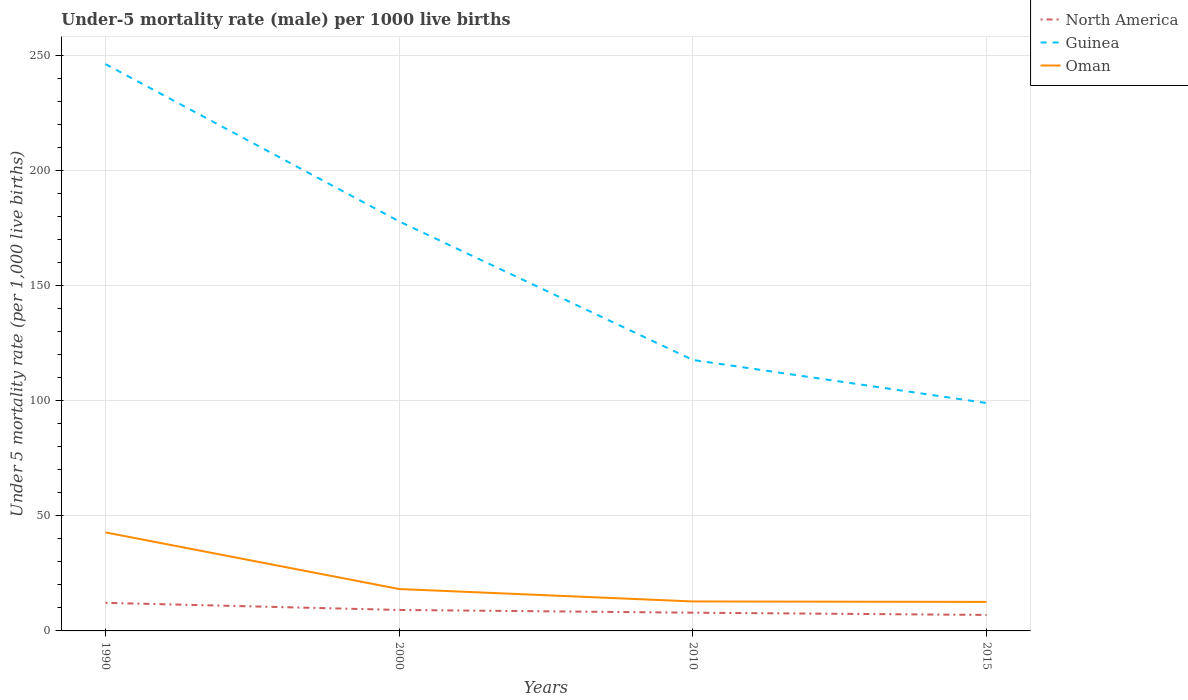Across all years, what is the maximum under-five mortality rate in Oman?
Provide a short and direct response. 12.6. In which year was the under-five mortality rate in Oman maximum?
Give a very brief answer. 2015. What is the total under-five mortality rate in Oman in the graph?
Ensure brevity in your answer.  0.2. What is the difference between the highest and the second highest under-five mortality rate in Guinea?
Your answer should be very brief. 147.2. Is the under-five mortality rate in Guinea strictly greater than the under-five mortality rate in North America over the years?
Provide a succinct answer. No. How many lines are there?
Make the answer very short. 3. How many years are there in the graph?
Your response must be concise. 4. What is the difference between two consecutive major ticks on the Y-axis?
Give a very brief answer. 50. Are the values on the major ticks of Y-axis written in scientific E-notation?
Provide a succinct answer. No. Does the graph contain any zero values?
Your response must be concise. No. How are the legend labels stacked?
Offer a terse response. Vertical. What is the title of the graph?
Keep it short and to the point. Under-5 mortality rate (male) per 1000 live births. Does "Liberia" appear as one of the legend labels in the graph?
Your answer should be compact. No. What is the label or title of the Y-axis?
Ensure brevity in your answer.  Under 5 mortality rate (per 1,0 live births). What is the Under 5 mortality rate (per 1,000 live births) of North America in 1990?
Provide a short and direct response. 12.2. What is the Under 5 mortality rate (per 1,000 live births) of Guinea in 1990?
Offer a very short reply. 246.2. What is the Under 5 mortality rate (per 1,000 live births) in Oman in 1990?
Your answer should be very brief. 42.8. What is the Under 5 mortality rate (per 1,000 live births) of North America in 2000?
Make the answer very short. 9.11. What is the Under 5 mortality rate (per 1,000 live births) in Guinea in 2000?
Offer a very short reply. 177.9. What is the Under 5 mortality rate (per 1,000 live births) of Oman in 2000?
Provide a short and direct response. 18.2. What is the Under 5 mortality rate (per 1,000 live births) of North America in 2010?
Provide a short and direct response. 7.92. What is the Under 5 mortality rate (per 1,000 live births) in Guinea in 2010?
Provide a short and direct response. 117.7. What is the Under 5 mortality rate (per 1,000 live births) of Oman in 2010?
Your answer should be compact. 12.8. What is the Under 5 mortality rate (per 1,000 live births) of North America in 2015?
Your answer should be compact. 6.94. What is the Under 5 mortality rate (per 1,000 live births) of Oman in 2015?
Your answer should be compact. 12.6. Across all years, what is the maximum Under 5 mortality rate (per 1,000 live births) of North America?
Provide a succinct answer. 12.2. Across all years, what is the maximum Under 5 mortality rate (per 1,000 live births) of Guinea?
Your response must be concise. 246.2. Across all years, what is the maximum Under 5 mortality rate (per 1,000 live births) in Oman?
Provide a short and direct response. 42.8. Across all years, what is the minimum Under 5 mortality rate (per 1,000 live births) in North America?
Your answer should be very brief. 6.94. Across all years, what is the minimum Under 5 mortality rate (per 1,000 live births) in Guinea?
Keep it short and to the point. 99. What is the total Under 5 mortality rate (per 1,000 live births) in North America in the graph?
Offer a terse response. 36.17. What is the total Under 5 mortality rate (per 1,000 live births) in Guinea in the graph?
Offer a very short reply. 640.8. What is the total Under 5 mortality rate (per 1,000 live births) in Oman in the graph?
Your answer should be compact. 86.4. What is the difference between the Under 5 mortality rate (per 1,000 live births) in North America in 1990 and that in 2000?
Ensure brevity in your answer.  3.09. What is the difference between the Under 5 mortality rate (per 1,000 live births) of Guinea in 1990 and that in 2000?
Offer a terse response. 68.3. What is the difference between the Under 5 mortality rate (per 1,000 live births) of Oman in 1990 and that in 2000?
Your answer should be compact. 24.6. What is the difference between the Under 5 mortality rate (per 1,000 live births) of North America in 1990 and that in 2010?
Offer a terse response. 4.28. What is the difference between the Under 5 mortality rate (per 1,000 live births) of Guinea in 1990 and that in 2010?
Your answer should be very brief. 128.5. What is the difference between the Under 5 mortality rate (per 1,000 live births) in Oman in 1990 and that in 2010?
Provide a short and direct response. 30. What is the difference between the Under 5 mortality rate (per 1,000 live births) in North America in 1990 and that in 2015?
Your response must be concise. 5.26. What is the difference between the Under 5 mortality rate (per 1,000 live births) of Guinea in 1990 and that in 2015?
Make the answer very short. 147.2. What is the difference between the Under 5 mortality rate (per 1,000 live births) of Oman in 1990 and that in 2015?
Keep it short and to the point. 30.2. What is the difference between the Under 5 mortality rate (per 1,000 live births) in North America in 2000 and that in 2010?
Ensure brevity in your answer.  1.19. What is the difference between the Under 5 mortality rate (per 1,000 live births) of Guinea in 2000 and that in 2010?
Your answer should be compact. 60.2. What is the difference between the Under 5 mortality rate (per 1,000 live births) in Oman in 2000 and that in 2010?
Ensure brevity in your answer.  5.4. What is the difference between the Under 5 mortality rate (per 1,000 live births) of North America in 2000 and that in 2015?
Your answer should be very brief. 2.17. What is the difference between the Under 5 mortality rate (per 1,000 live births) of Guinea in 2000 and that in 2015?
Your answer should be very brief. 78.9. What is the difference between the Under 5 mortality rate (per 1,000 live births) of Guinea in 2010 and that in 2015?
Your answer should be compact. 18.7. What is the difference between the Under 5 mortality rate (per 1,000 live births) of North America in 1990 and the Under 5 mortality rate (per 1,000 live births) of Guinea in 2000?
Your answer should be compact. -165.7. What is the difference between the Under 5 mortality rate (per 1,000 live births) of North America in 1990 and the Under 5 mortality rate (per 1,000 live births) of Oman in 2000?
Give a very brief answer. -6. What is the difference between the Under 5 mortality rate (per 1,000 live births) in Guinea in 1990 and the Under 5 mortality rate (per 1,000 live births) in Oman in 2000?
Make the answer very short. 228. What is the difference between the Under 5 mortality rate (per 1,000 live births) of North America in 1990 and the Under 5 mortality rate (per 1,000 live births) of Guinea in 2010?
Your answer should be compact. -105.5. What is the difference between the Under 5 mortality rate (per 1,000 live births) of North America in 1990 and the Under 5 mortality rate (per 1,000 live births) of Oman in 2010?
Your answer should be very brief. -0.6. What is the difference between the Under 5 mortality rate (per 1,000 live births) of Guinea in 1990 and the Under 5 mortality rate (per 1,000 live births) of Oman in 2010?
Offer a very short reply. 233.4. What is the difference between the Under 5 mortality rate (per 1,000 live births) in North America in 1990 and the Under 5 mortality rate (per 1,000 live births) in Guinea in 2015?
Give a very brief answer. -86.8. What is the difference between the Under 5 mortality rate (per 1,000 live births) in North America in 1990 and the Under 5 mortality rate (per 1,000 live births) in Oman in 2015?
Offer a terse response. -0.4. What is the difference between the Under 5 mortality rate (per 1,000 live births) in Guinea in 1990 and the Under 5 mortality rate (per 1,000 live births) in Oman in 2015?
Give a very brief answer. 233.6. What is the difference between the Under 5 mortality rate (per 1,000 live births) in North America in 2000 and the Under 5 mortality rate (per 1,000 live births) in Guinea in 2010?
Ensure brevity in your answer.  -108.59. What is the difference between the Under 5 mortality rate (per 1,000 live births) of North America in 2000 and the Under 5 mortality rate (per 1,000 live births) of Oman in 2010?
Your answer should be compact. -3.69. What is the difference between the Under 5 mortality rate (per 1,000 live births) of Guinea in 2000 and the Under 5 mortality rate (per 1,000 live births) of Oman in 2010?
Provide a succinct answer. 165.1. What is the difference between the Under 5 mortality rate (per 1,000 live births) in North America in 2000 and the Under 5 mortality rate (per 1,000 live births) in Guinea in 2015?
Offer a terse response. -89.89. What is the difference between the Under 5 mortality rate (per 1,000 live births) of North America in 2000 and the Under 5 mortality rate (per 1,000 live births) of Oman in 2015?
Your answer should be very brief. -3.49. What is the difference between the Under 5 mortality rate (per 1,000 live births) in Guinea in 2000 and the Under 5 mortality rate (per 1,000 live births) in Oman in 2015?
Provide a short and direct response. 165.3. What is the difference between the Under 5 mortality rate (per 1,000 live births) of North America in 2010 and the Under 5 mortality rate (per 1,000 live births) of Guinea in 2015?
Provide a short and direct response. -91.08. What is the difference between the Under 5 mortality rate (per 1,000 live births) of North America in 2010 and the Under 5 mortality rate (per 1,000 live births) of Oman in 2015?
Make the answer very short. -4.68. What is the difference between the Under 5 mortality rate (per 1,000 live births) in Guinea in 2010 and the Under 5 mortality rate (per 1,000 live births) in Oman in 2015?
Your answer should be very brief. 105.1. What is the average Under 5 mortality rate (per 1,000 live births) of North America per year?
Give a very brief answer. 9.04. What is the average Under 5 mortality rate (per 1,000 live births) in Guinea per year?
Ensure brevity in your answer.  160.2. What is the average Under 5 mortality rate (per 1,000 live births) in Oman per year?
Your answer should be compact. 21.6. In the year 1990, what is the difference between the Under 5 mortality rate (per 1,000 live births) in North America and Under 5 mortality rate (per 1,000 live births) in Guinea?
Make the answer very short. -234. In the year 1990, what is the difference between the Under 5 mortality rate (per 1,000 live births) of North America and Under 5 mortality rate (per 1,000 live births) of Oman?
Your answer should be compact. -30.6. In the year 1990, what is the difference between the Under 5 mortality rate (per 1,000 live births) in Guinea and Under 5 mortality rate (per 1,000 live births) in Oman?
Keep it short and to the point. 203.4. In the year 2000, what is the difference between the Under 5 mortality rate (per 1,000 live births) in North America and Under 5 mortality rate (per 1,000 live births) in Guinea?
Keep it short and to the point. -168.79. In the year 2000, what is the difference between the Under 5 mortality rate (per 1,000 live births) of North America and Under 5 mortality rate (per 1,000 live births) of Oman?
Your answer should be compact. -9.09. In the year 2000, what is the difference between the Under 5 mortality rate (per 1,000 live births) of Guinea and Under 5 mortality rate (per 1,000 live births) of Oman?
Offer a very short reply. 159.7. In the year 2010, what is the difference between the Under 5 mortality rate (per 1,000 live births) in North America and Under 5 mortality rate (per 1,000 live births) in Guinea?
Your answer should be compact. -109.78. In the year 2010, what is the difference between the Under 5 mortality rate (per 1,000 live births) in North America and Under 5 mortality rate (per 1,000 live births) in Oman?
Ensure brevity in your answer.  -4.88. In the year 2010, what is the difference between the Under 5 mortality rate (per 1,000 live births) of Guinea and Under 5 mortality rate (per 1,000 live births) of Oman?
Offer a terse response. 104.9. In the year 2015, what is the difference between the Under 5 mortality rate (per 1,000 live births) in North America and Under 5 mortality rate (per 1,000 live births) in Guinea?
Provide a short and direct response. -92.06. In the year 2015, what is the difference between the Under 5 mortality rate (per 1,000 live births) in North America and Under 5 mortality rate (per 1,000 live births) in Oman?
Your answer should be compact. -5.66. In the year 2015, what is the difference between the Under 5 mortality rate (per 1,000 live births) in Guinea and Under 5 mortality rate (per 1,000 live births) in Oman?
Your answer should be very brief. 86.4. What is the ratio of the Under 5 mortality rate (per 1,000 live births) of North America in 1990 to that in 2000?
Ensure brevity in your answer.  1.34. What is the ratio of the Under 5 mortality rate (per 1,000 live births) of Guinea in 1990 to that in 2000?
Make the answer very short. 1.38. What is the ratio of the Under 5 mortality rate (per 1,000 live births) of Oman in 1990 to that in 2000?
Your answer should be compact. 2.35. What is the ratio of the Under 5 mortality rate (per 1,000 live births) of North America in 1990 to that in 2010?
Offer a terse response. 1.54. What is the ratio of the Under 5 mortality rate (per 1,000 live births) of Guinea in 1990 to that in 2010?
Provide a succinct answer. 2.09. What is the ratio of the Under 5 mortality rate (per 1,000 live births) of Oman in 1990 to that in 2010?
Provide a succinct answer. 3.34. What is the ratio of the Under 5 mortality rate (per 1,000 live births) in North America in 1990 to that in 2015?
Make the answer very short. 1.76. What is the ratio of the Under 5 mortality rate (per 1,000 live births) in Guinea in 1990 to that in 2015?
Make the answer very short. 2.49. What is the ratio of the Under 5 mortality rate (per 1,000 live births) in Oman in 1990 to that in 2015?
Provide a short and direct response. 3.4. What is the ratio of the Under 5 mortality rate (per 1,000 live births) of North America in 2000 to that in 2010?
Provide a short and direct response. 1.15. What is the ratio of the Under 5 mortality rate (per 1,000 live births) of Guinea in 2000 to that in 2010?
Provide a succinct answer. 1.51. What is the ratio of the Under 5 mortality rate (per 1,000 live births) in Oman in 2000 to that in 2010?
Make the answer very short. 1.42. What is the ratio of the Under 5 mortality rate (per 1,000 live births) in North America in 2000 to that in 2015?
Provide a short and direct response. 1.31. What is the ratio of the Under 5 mortality rate (per 1,000 live births) in Guinea in 2000 to that in 2015?
Keep it short and to the point. 1.8. What is the ratio of the Under 5 mortality rate (per 1,000 live births) in Oman in 2000 to that in 2015?
Give a very brief answer. 1.44. What is the ratio of the Under 5 mortality rate (per 1,000 live births) of North America in 2010 to that in 2015?
Your answer should be very brief. 1.14. What is the ratio of the Under 5 mortality rate (per 1,000 live births) in Guinea in 2010 to that in 2015?
Keep it short and to the point. 1.19. What is the ratio of the Under 5 mortality rate (per 1,000 live births) in Oman in 2010 to that in 2015?
Give a very brief answer. 1.02. What is the difference between the highest and the second highest Under 5 mortality rate (per 1,000 live births) in North America?
Offer a terse response. 3.09. What is the difference between the highest and the second highest Under 5 mortality rate (per 1,000 live births) of Guinea?
Ensure brevity in your answer.  68.3. What is the difference between the highest and the second highest Under 5 mortality rate (per 1,000 live births) in Oman?
Make the answer very short. 24.6. What is the difference between the highest and the lowest Under 5 mortality rate (per 1,000 live births) in North America?
Give a very brief answer. 5.26. What is the difference between the highest and the lowest Under 5 mortality rate (per 1,000 live births) in Guinea?
Make the answer very short. 147.2. What is the difference between the highest and the lowest Under 5 mortality rate (per 1,000 live births) in Oman?
Your answer should be compact. 30.2. 